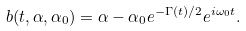Convert formula to latex. <formula><loc_0><loc_0><loc_500><loc_500>b ( t , \alpha , \alpha _ { 0 } ) = \alpha - \alpha _ { 0 } e ^ { - \Gamma ( t ) / 2 } e ^ { i \omega _ { 0 } t } .</formula> 